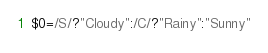<code> <loc_0><loc_0><loc_500><loc_500><_Awk_>$0=/S/?"Cloudy":/C/?"Rainy":"Sunny"</code> 